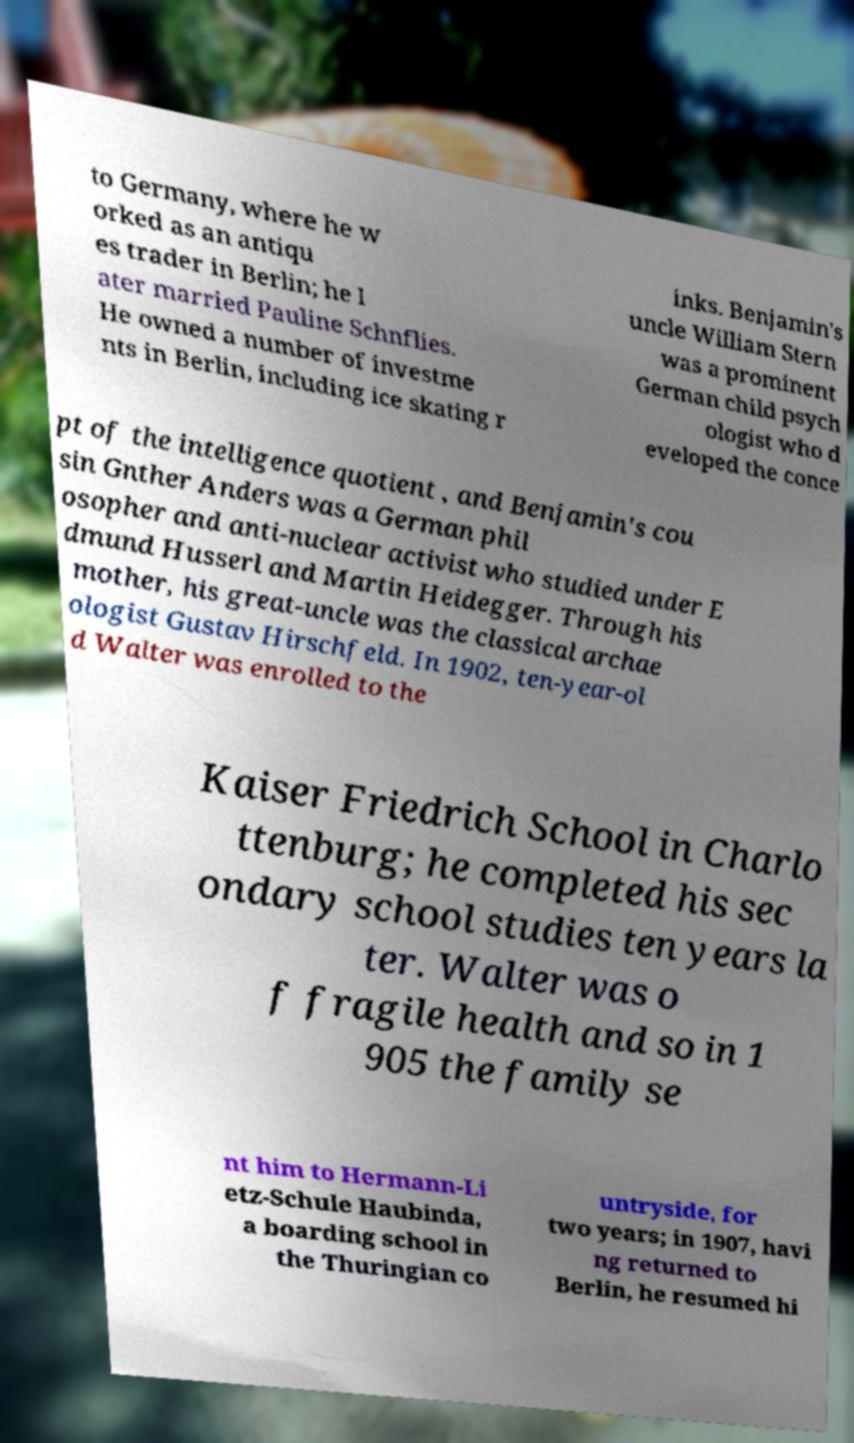Please identify and transcribe the text found in this image. to Germany, where he w orked as an antiqu es trader in Berlin; he l ater married Pauline Schnflies. He owned a number of investme nts in Berlin, including ice skating r inks. Benjamin's uncle William Stern was a prominent German child psych ologist who d eveloped the conce pt of the intelligence quotient , and Benjamin's cou sin Gnther Anders was a German phil osopher and anti-nuclear activist who studied under E dmund Husserl and Martin Heidegger. Through his mother, his great-uncle was the classical archae ologist Gustav Hirschfeld. In 1902, ten-year-ol d Walter was enrolled to the Kaiser Friedrich School in Charlo ttenburg; he completed his sec ondary school studies ten years la ter. Walter was o f fragile health and so in 1 905 the family se nt him to Hermann-Li etz-Schule Haubinda, a boarding school in the Thuringian co untryside, for two years; in 1907, havi ng returned to Berlin, he resumed hi 